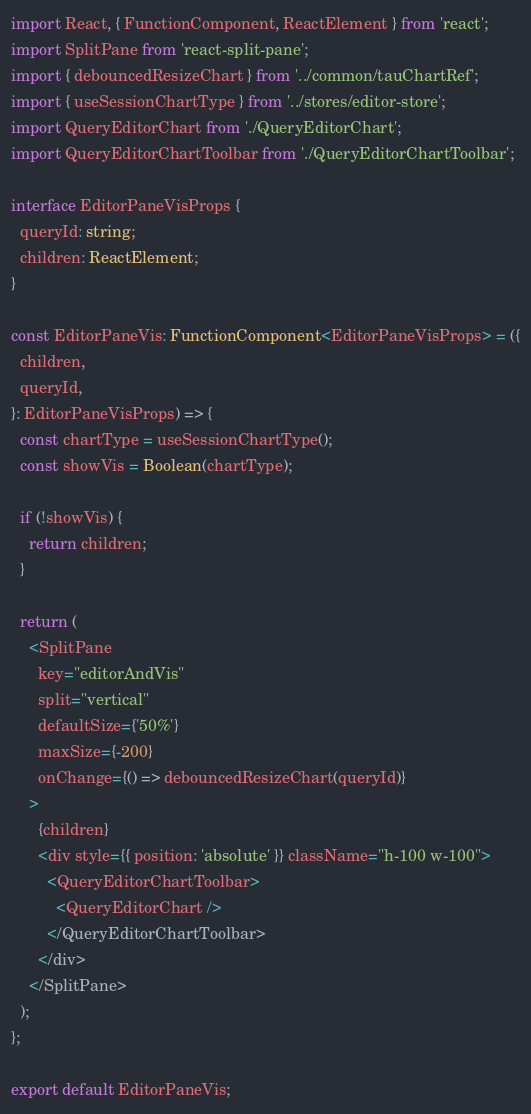Convert code to text. <code><loc_0><loc_0><loc_500><loc_500><_TypeScript_>import React, { FunctionComponent, ReactElement } from 'react';
import SplitPane from 'react-split-pane';
import { debouncedResizeChart } from '../common/tauChartRef';
import { useSessionChartType } from '../stores/editor-store';
import QueryEditorChart from './QueryEditorChart';
import QueryEditorChartToolbar from './QueryEditorChartToolbar';

interface EditorPaneVisProps {
  queryId: string;
  children: ReactElement;
}

const EditorPaneVis: FunctionComponent<EditorPaneVisProps> = ({
  children,
  queryId,
}: EditorPaneVisProps) => {
  const chartType = useSessionChartType();
  const showVis = Boolean(chartType);

  if (!showVis) {
    return children;
  }

  return (
    <SplitPane
      key="editorAndVis"
      split="vertical"
      defaultSize={'50%'}
      maxSize={-200}
      onChange={() => debouncedResizeChart(queryId)}
    >
      {children}
      <div style={{ position: 'absolute' }} className="h-100 w-100">
        <QueryEditorChartToolbar>
          <QueryEditorChart />
        </QueryEditorChartToolbar>
      </div>
    </SplitPane>
  );
};

export default EditorPaneVis;
</code> 